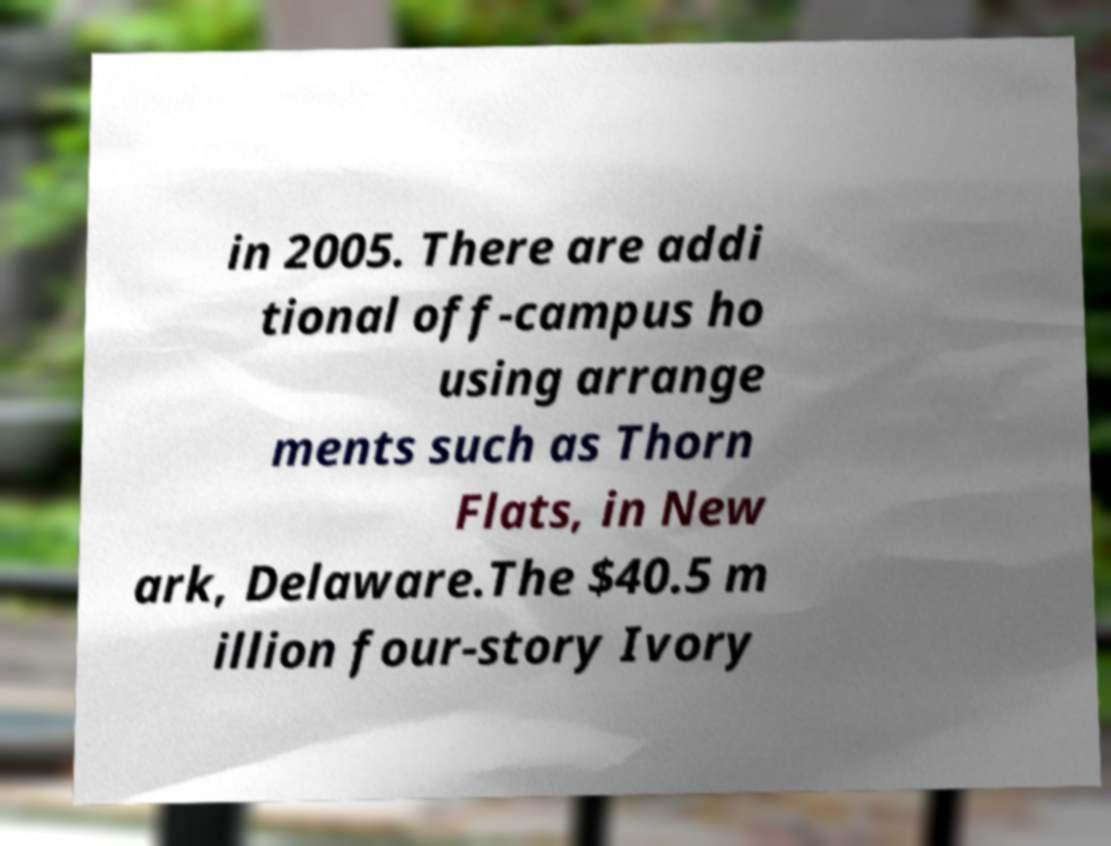Can you accurately transcribe the text from the provided image for me? in 2005. There are addi tional off-campus ho using arrange ments such as Thorn Flats, in New ark, Delaware.The $40.5 m illion four-story Ivory 